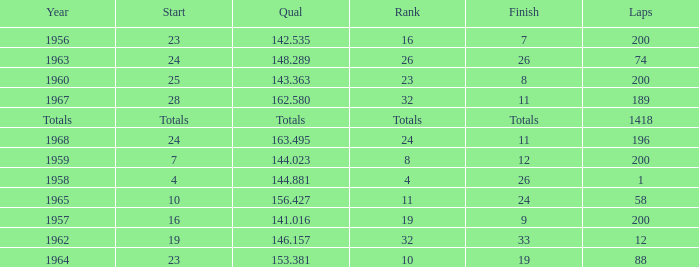Which qual has both 200 total laps and took place in 1957? 141.016. 